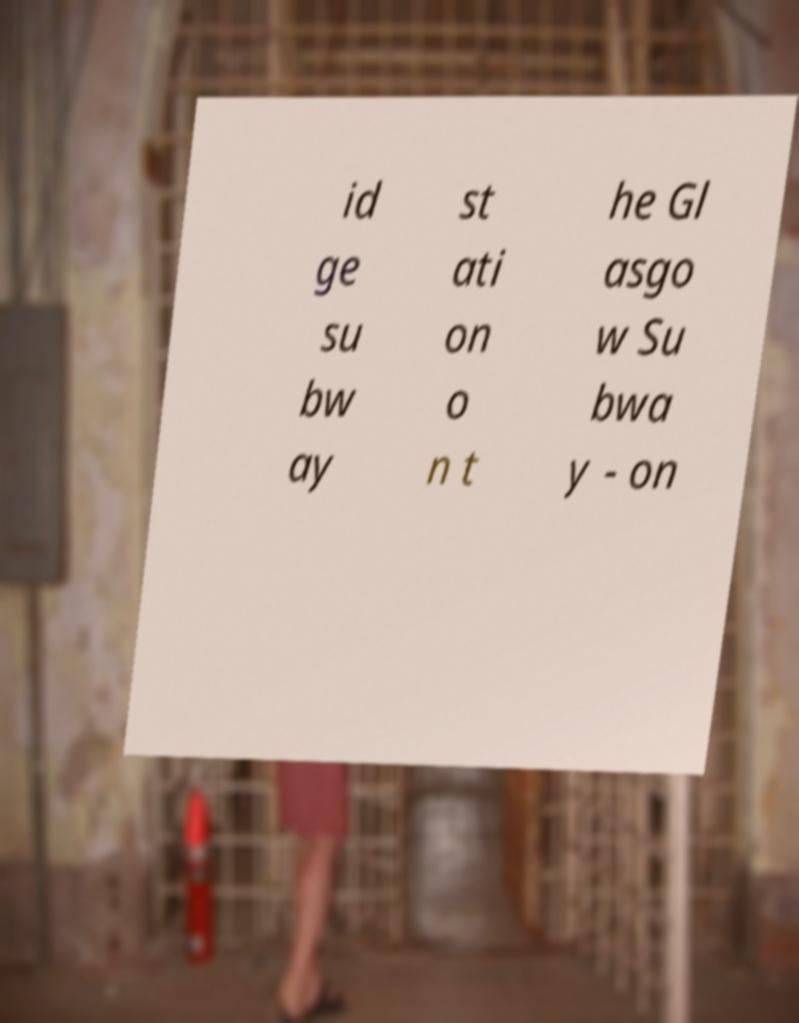I need the written content from this picture converted into text. Can you do that? id ge su bw ay st ati on o n t he Gl asgo w Su bwa y - on 